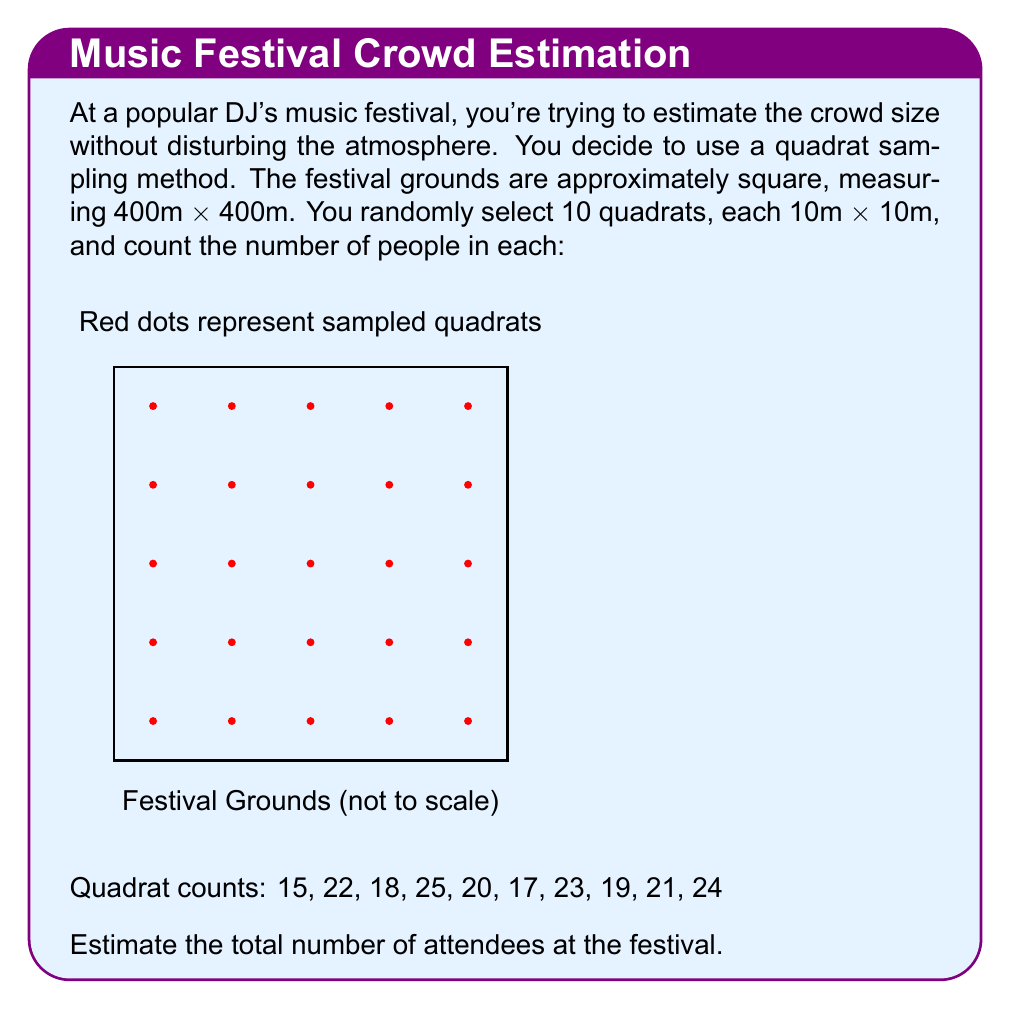Give your solution to this math problem. Let's approach this step-by-step:

1) First, we need to calculate the average number of people per quadrat:

   $\bar{x} = \frac{15 + 22 + 18 + 25 + 20 + 17 + 23 + 19 + 21 + 24}{10} = 20.4$ people/quadrat

2) Now, we need to determine how many quadrats would fit in the entire festival grounds:
   
   Total area = 400m × 400m = 160,000 m²
   Quadrat area = 10m × 10m = 100 m²
   Number of quadrats = $\frac{160,000}{100} = 1,600$ quadrats

3) To estimate the total number of attendees, we multiply the average number of people per quadrat by the total number of quadrats:

   Estimated attendees = 20.4 × 1,600 = 32,640

4) However, it's good practice to round this to a reasonable number of significant figures, given the uncertainty in our sampling method. Let's round to the nearest hundred:

   Estimated attendees ≈ 32,600

This method assumes that the density of people is relatively uniform across the festival grounds, which may not always be the case in real-world scenarios. More sophisticated sampling methods might be used for greater accuracy.
Answer: 32,600 attendees 